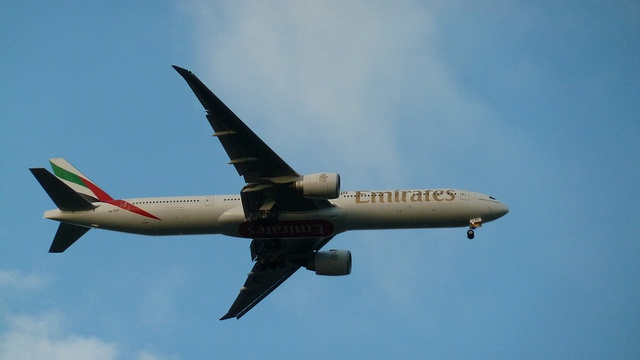Describe the objects in this image and their specific colors. I can see a airplane in gray, black, and darkgray tones in this image. 